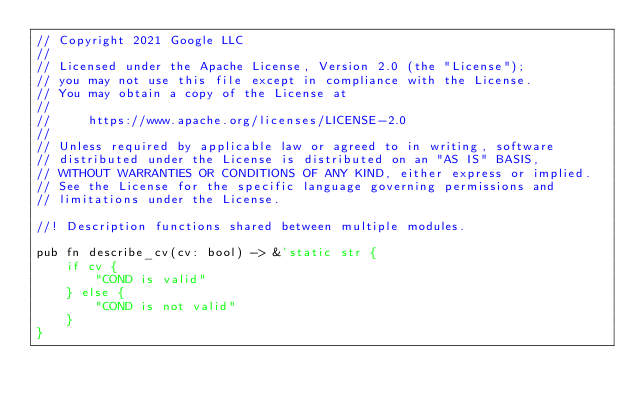Convert code to text. <code><loc_0><loc_0><loc_500><loc_500><_Rust_>// Copyright 2021 Google LLC
//
// Licensed under the Apache License, Version 2.0 (the "License");
// you may not use this file except in compliance with the License.
// You may obtain a copy of the License at
//
//     https://www.apache.org/licenses/LICENSE-2.0
//
// Unless required by applicable law or agreed to in writing, software
// distributed under the License is distributed on an "AS IS" BASIS,
// WITHOUT WARRANTIES OR CONDITIONS OF ANY KIND, either express or implied.
// See the License for the specific language governing permissions and
// limitations under the License.

//! Description functions shared between multiple modules.

pub fn describe_cv(cv: bool) -> &'static str {
    if cv {
        "COND is valid"
    } else {
        "COND is not valid"
    }
}
</code> 